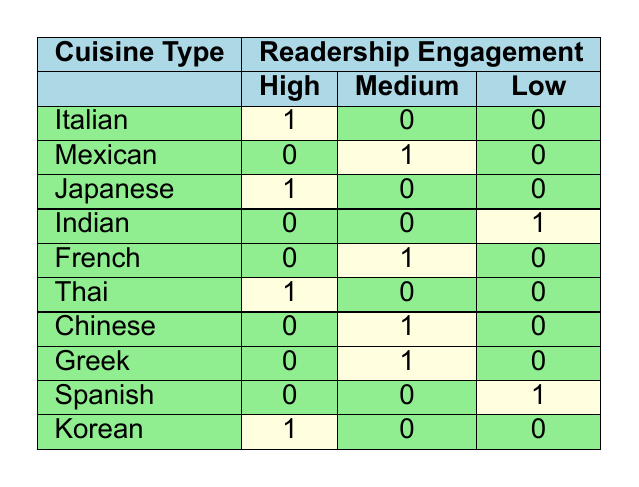What cuisine type has the highest readership engagement? The table shows that Italian, Japanese, Thai, and Korean all have a "High" readership engagement. However, the question asks for the cuisine type, so the answer could refer to any of these.
Answer: Italian, Japanese, Thai, Korean How many cuisine types have a medium level of readership engagement? From the table, the cuisine types with "Medium" readership engagement are Mexican, French, Chinese, and Greek. Counting them gives a total of 4.
Answer: 4 Is there a cuisine type that has no engagement at all? Looking at the table, all cuisine types listed have some level of readership engagement (High, Medium, or Low) and none of them have zero engagement.
Answer: No Which cuisine type has the lowest engagement? The table shows that Indian and Spanish cuisines both have a "Low" readership engagement. Hence, the lowest engagement applies to both cuisines.
Answer: Indian, Spanish How many total cuisine types are categorized as high engagement? Counting from the table, there are four cuisine types that fall under "High" engagement: Italian, Japanese, Thai, and Korean. Therefore, the total is 4.
Answer: 4 Are there more cuisines with medium engagement than with low engagement? The table shows there are 4 cuisines with "Medium" engagement (Mexican, French, Chinese, Greek) and 2 cuisines with "Low" engagement (Indian, Spanish). Thus, there are more medium engagement cuisines.
Answer: Yes Which cuisine has high engagement but does not have medium engagement? From the table, the cuisines that have "High" engagement are Italian, Japanese, Thai, and Korean. The cuisines that qualify without a "Medium" engagement are Italian, Japanese, Thai, and Korean, meaning all these high engagement cuisines are indeed without medium engagement.
Answer: Italian, Japanese, Thai, Korean What is the ratio of cuisines with high engagement to those with low engagement? Four cuisines have "High" engagement (Italian, Japanese, Thai, Korean), and two have "Low" engagement (Indian, Spanish). Thus, the ratio can be computed as 4 to 2, which simplifies to 2 to 1.
Answer: 2:1 